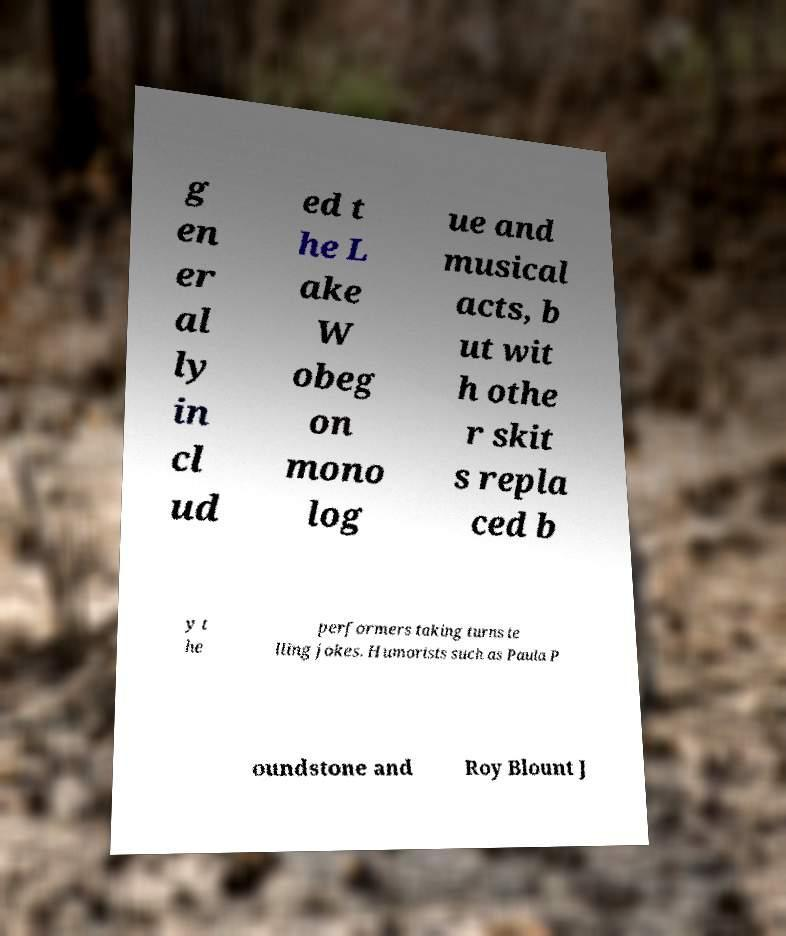Can you accurately transcribe the text from the provided image for me? g en er al ly in cl ud ed t he L ake W obeg on mono log ue and musical acts, b ut wit h othe r skit s repla ced b y t he performers taking turns te lling jokes. Humorists such as Paula P oundstone and Roy Blount J 